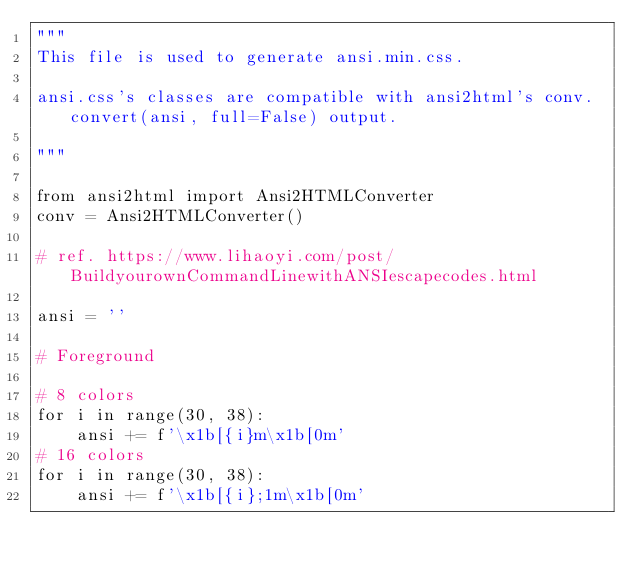<code> <loc_0><loc_0><loc_500><loc_500><_Python_>"""
This file is used to generate ansi.min.css.

ansi.css's classes are compatible with ansi2html's conv.convert(ansi, full=False) output.

"""

from ansi2html import Ansi2HTMLConverter
conv = Ansi2HTMLConverter()

# ref. https://www.lihaoyi.com/post/BuildyourownCommandLinewithANSIescapecodes.html

ansi = ''

# Foreground

# 8 colors
for i in range(30, 38):
    ansi += f'\x1b[{i}m\x1b[0m'
# 16 colors
for i in range(30, 38):
    ansi += f'\x1b[{i};1m\x1b[0m'</code> 